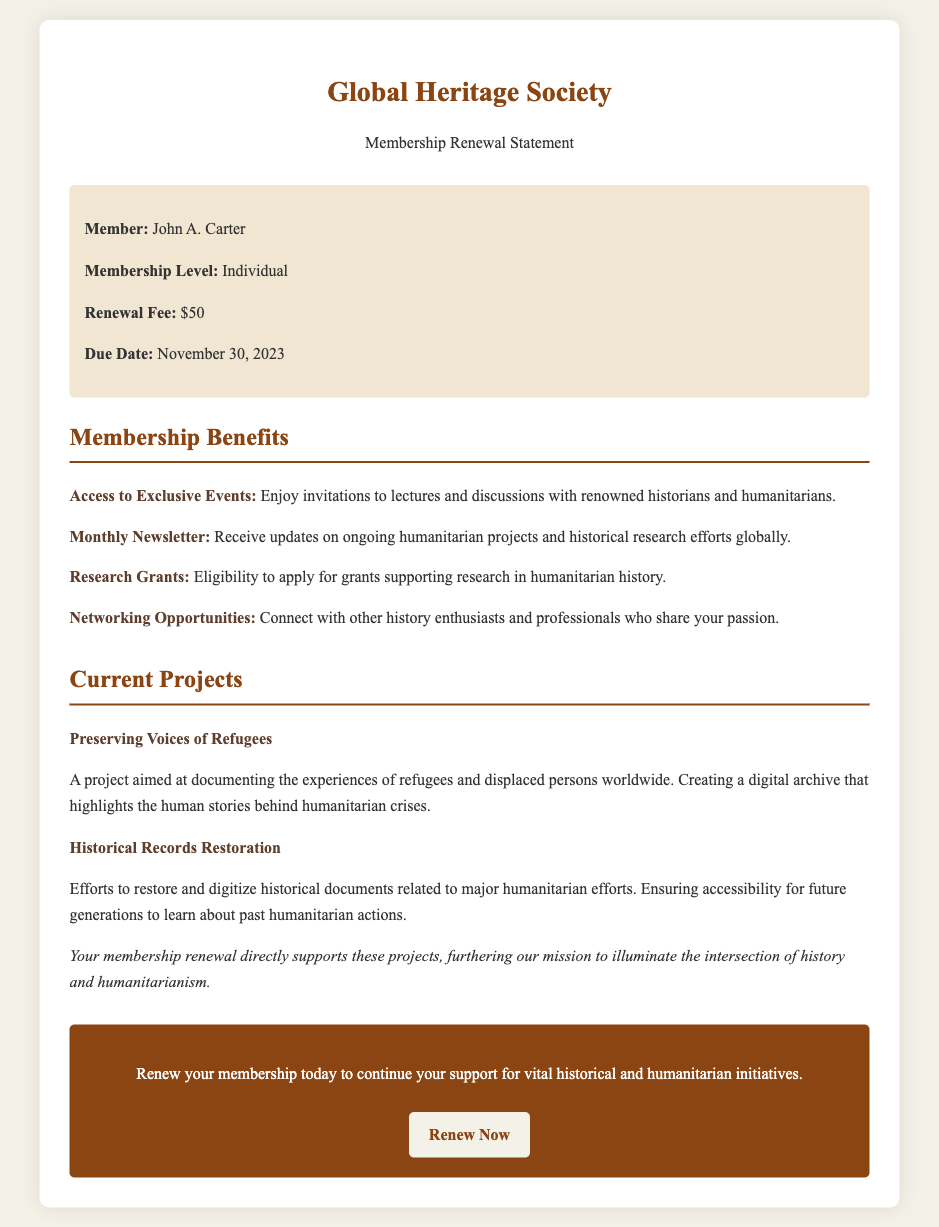What is the member's name? The member's name is stated in the member info section of the document.
Answer: John A. Carter What is the membership renewal fee? The fee is explicitly listed under the member info section in the document.
Answer: $50 What is the due date for the membership renewal? The due date is specified in the member information portion of the document.
Answer: November 30, 2023 What benefit provides updates on projects? This benefit is described in the membership benefits section of the document.
Answer: Monthly Newsletter What is the title of the current project focused on refugees? The title can be found in the projects section of the document under current projects.
Answer: Preserving Voices of Refugees How does the membership renewal contribute to ongoing efforts? This information is found in the projects section highlighting the impact of the membership.
Answer: Supports projects directly What is one way members can connect with others? This is mentioned in the benefits section as a form of membership advantage.
Answer: Networking Opportunities What type of grants can members apply for? The type of grants is mentioned in the benefits section regarding member eligibility.
Answer: Research Grants 